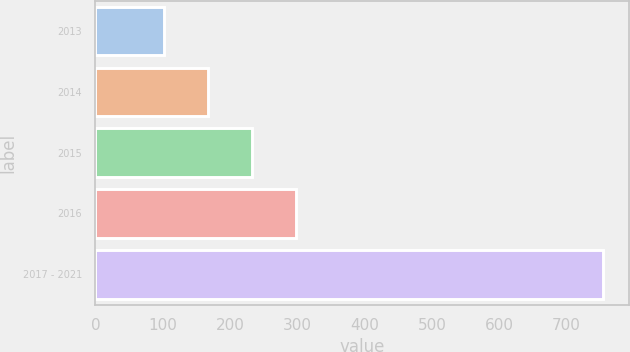<chart> <loc_0><loc_0><loc_500><loc_500><bar_chart><fcel>2013<fcel>2014<fcel>2015<fcel>2016<fcel>2017 - 2021<nl><fcel>102<fcel>167.3<fcel>232.6<fcel>297.9<fcel>755<nl></chart> 